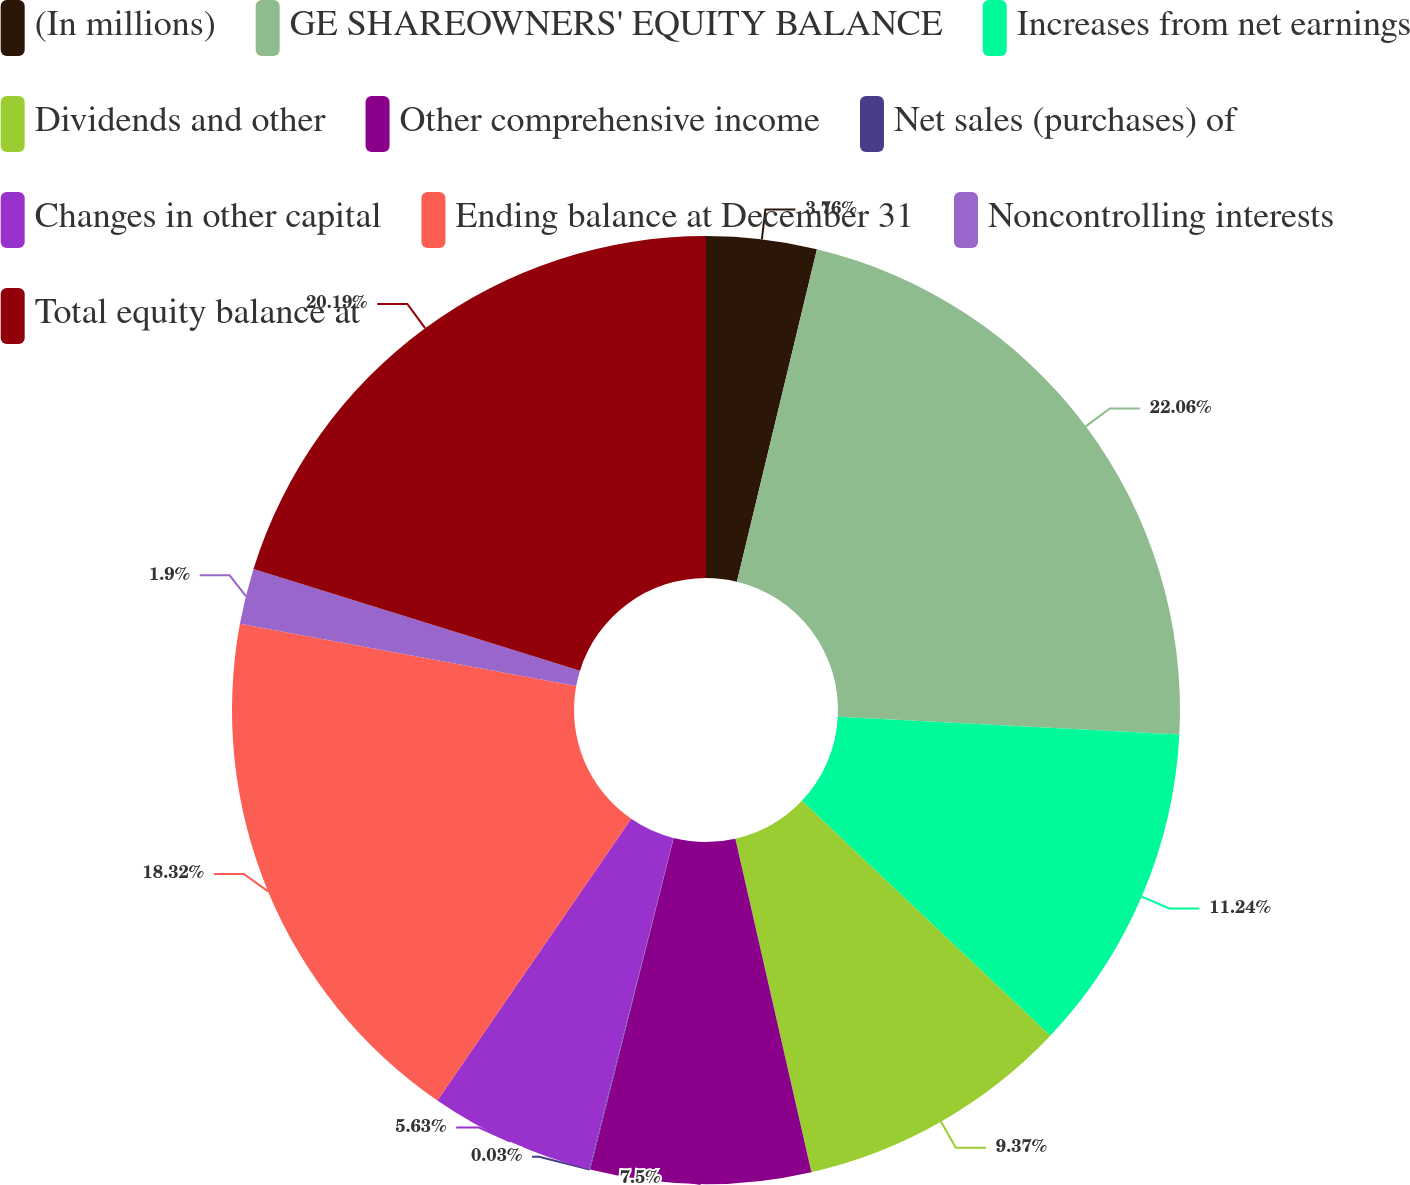Convert chart to OTSL. <chart><loc_0><loc_0><loc_500><loc_500><pie_chart><fcel>(In millions)<fcel>GE SHAREOWNERS' EQUITY BALANCE<fcel>Increases from net earnings<fcel>Dividends and other<fcel>Other comprehensive income<fcel>Net sales (purchases) of<fcel>Changes in other capital<fcel>Ending balance at December 31<fcel>Noncontrolling interests<fcel>Total equity balance at<nl><fcel>3.76%<fcel>22.06%<fcel>11.24%<fcel>9.37%<fcel>7.5%<fcel>0.03%<fcel>5.63%<fcel>18.32%<fcel>1.9%<fcel>20.19%<nl></chart> 